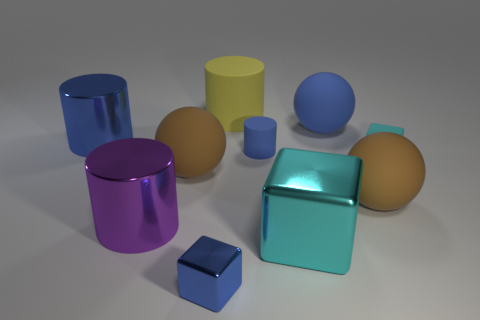Can you tell me the colors of the objects excluding the yellow ones? Certainly! Aside from the yellow objects, there are objects in blue, purple, aqua, and two in a shade of peach or beige. 